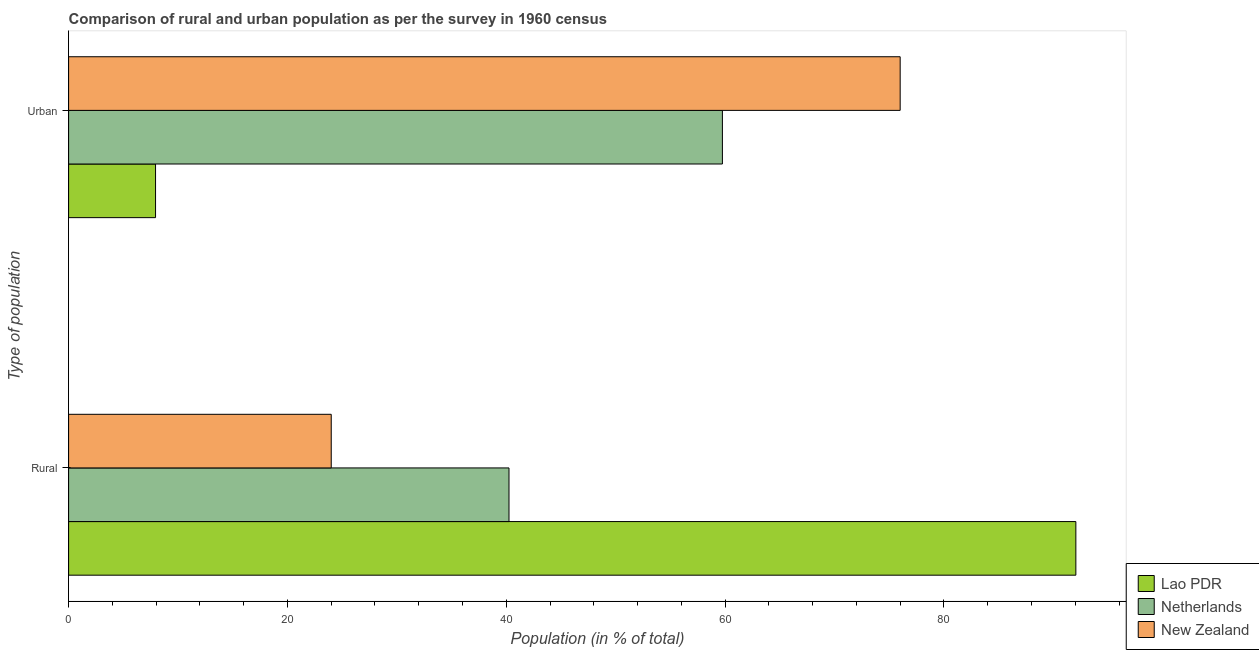How many groups of bars are there?
Your answer should be very brief. 2. Are the number of bars per tick equal to the number of legend labels?
Give a very brief answer. Yes. Are the number of bars on each tick of the Y-axis equal?
Offer a very short reply. Yes. How many bars are there on the 2nd tick from the bottom?
Offer a very short reply. 3. What is the label of the 1st group of bars from the top?
Offer a terse response. Urban. What is the rural population in Lao PDR?
Your response must be concise. 92.05. Across all countries, what is the maximum rural population?
Make the answer very short. 92.05. Across all countries, what is the minimum urban population?
Offer a very short reply. 7.95. In which country was the urban population maximum?
Your response must be concise. New Zealand. In which country was the rural population minimum?
Give a very brief answer. New Zealand. What is the total rural population in the graph?
Make the answer very short. 156.3. What is the difference between the urban population in Netherlands and that in New Zealand?
Provide a short and direct response. -16.25. What is the difference between the urban population in New Zealand and the rural population in Lao PDR?
Offer a very short reply. -16.06. What is the average urban population per country?
Make the answer very short. 47.9. What is the difference between the rural population and urban population in Lao PDR?
Give a very brief answer. 84.11. In how many countries, is the rural population greater than 44 %?
Provide a short and direct response. 1. What is the ratio of the rural population in Netherlands to that in Lao PDR?
Ensure brevity in your answer.  0.44. Is the urban population in Lao PDR less than that in New Zealand?
Your answer should be compact. Yes. In how many countries, is the rural population greater than the average rural population taken over all countries?
Provide a succinct answer. 1. What does the 1st bar from the top in Urban represents?
Provide a succinct answer. New Zealand. What does the 3rd bar from the bottom in Urban represents?
Give a very brief answer. New Zealand. How many bars are there?
Your answer should be compact. 6. How many countries are there in the graph?
Make the answer very short. 3. What is the difference between two consecutive major ticks on the X-axis?
Provide a short and direct response. 20. Are the values on the major ticks of X-axis written in scientific E-notation?
Provide a short and direct response. No. How many legend labels are there?
Ensure brevity in your answer.  3. How are the legend labels stacked?
Keep it short and to the point. Vertical. What is the title of the graph?
Give a very brief answer. Comparison of rural and urban population as per the survey in 1960 census. Does "Indonesia" appear as one of the legend labels in the graph?
Your answer should be very brief. No. What is the label or title of the X-axis?
Offer a very short reply. Population (in % of total). What is the label or title of the Y-axis?
Ensure brevity in your answer.  Type of population. What is the Population (in % of total) in Lao PDR in Rural?
Give a very brief answer. 92.05. What is the Population (in % of total) in Netherlands in Rural?
Make the answer very short. 40.25. What is the Population (in % of total) in New Zealand in Rural?
Keep it short and to the point. 24. What is the Population (in % of total) in Lao PDR in Urban?
Provide a succinct answer. 7.95. What is the Population (in % of total) of Netherlands in Urban?
Provide a succinct answer. 59.75. What is the Population (in % of total) in New Zealand in Urban?
Your answer should be very brief. 76. Across all Type of population, what is the maximum Population (in % of total) of Lao PDR?
Offer a very short reply. 92.05. Across all Type of population, what is the maximum Population (in % of total) in Netherlands?
Provide a succinct answer. 59.75. Across all Type of population, what is the maximum Population (in % of total) of New Zealand?
Give a very brief answer. 76. Across all Type of population, what is the minimum Population (in % of total) in Lao PDR?
Provide a succinct answer. 7.95. Across all Type of population, what is the minimum Population (in % of total) of Netherlands?
Offer a terse response. 40.25. Across all Type of population, what is the minimum Population (in % of total) of New Zealand?
Provide a short and direct response. 24. What is the total Population (in % of total) in Lao PDR in the graph?
Offer a terse response. 100. What is the total Population (in % of total) in New Zealand in the graph?
Make the answer very short. 100. What is the difference between the Population (in % of total) of Lao PDR in Rural and that in Urban?
Your answer should be very brief. 84.11. What is the difference between the Population (in % of total) in Netherlands in Rural and that in Urban?
Provide a succinct answer. -19.5. What is the difference between the Population (in % of total) of New Zealand in Rural and that in Urban?
Ensure brevity in your answer.  -52. What is the difference between the Population (in % of total) of Lao PDR in Rural and the Population (in % of total) of Netherlands in Urban?
Make the answer very short. 32.3. What is the difference between the Population (in % of total) in Lao PDR in Rural and the Population (in % of total) in New Zealand in Urban?
Provide a succinct answer. 16.06. What is the difference between the Population (in % of total) in Netherlands in Rural and the Population (in % of total) in New Zealand in Urban?
Offer a terse response. -35.75. What is the average Population (in % of total) of Lao PDR per Type of population?
Provide a short and direct response. 50. What is the average Population (in % of total) of New Zealand per Type of population?
Give a very brief answer. 50. What is the difference between the Population (in % of total) in Lao PDR and Population (in % of total) in Netherlands in Rural?
Give a very brief answer. 51.81. What is the difference between the Population (in % of total) of Lao PDR and Population (in % of total) of New Zealand in Rural?
Keep it short and to the point. 68.05. What is the difference between the Population (in % of total) of Netherlands and Population (in % of total) of New Zealand in Rural?
Provide a short and direct response. 16.25. What is the difference between the Population (in % of total) in Lao PDR and Population (in % of total) in Netherlands in Urban?
Keep it short and to the point. -51.81. What is the difference between the Population (in % of total) of Lao PDR and Population (in % of total) of New Zealand in Urban?
Provide a short and direct response. -68.05. What is the difference between the Population (in % of total) in Netherlands and Population (in % of total) in New Zealand in Urban?
Offer a very short reply. -16.25. What is the ratio of the Population (in % of total) of Lao PDR in Rural to that in Urban?
Provide a succinct answer. 11.58. What is the ratio of the Population (in % of total) in Netherlands in Rural to that in Urban?
Make the answer very short. 0.67. What is the ratio of the Population (in % of total) in New Zealand in Rural to that in Urban?
Ensure brevity in your answer.  0.32. What is the difference between the highest and the second highest Population (in % of total) in Lao PDR?
Provide a short and direct response. 84.11. What is the difference between the highest and the second highest Population (in % of total) of Netherlands?
Your answer should be compact. 19.5. What is the difference between the highest and the second highest Population (in % of total) in New Zealand?
Provide a succinct answer. 52. What is the difference between the highest and the lowest Population (in % of total) of Lao PDR?
Your response must be concise. 84.11. What is the difference between the highest and the lowest Population (in % of total) in Netherlands?
Provide a succinct answer. 19.5. What is the difference between the highest and the lowest Population (in % of total) in New Zealand?
Give a very brief answer. 52. 